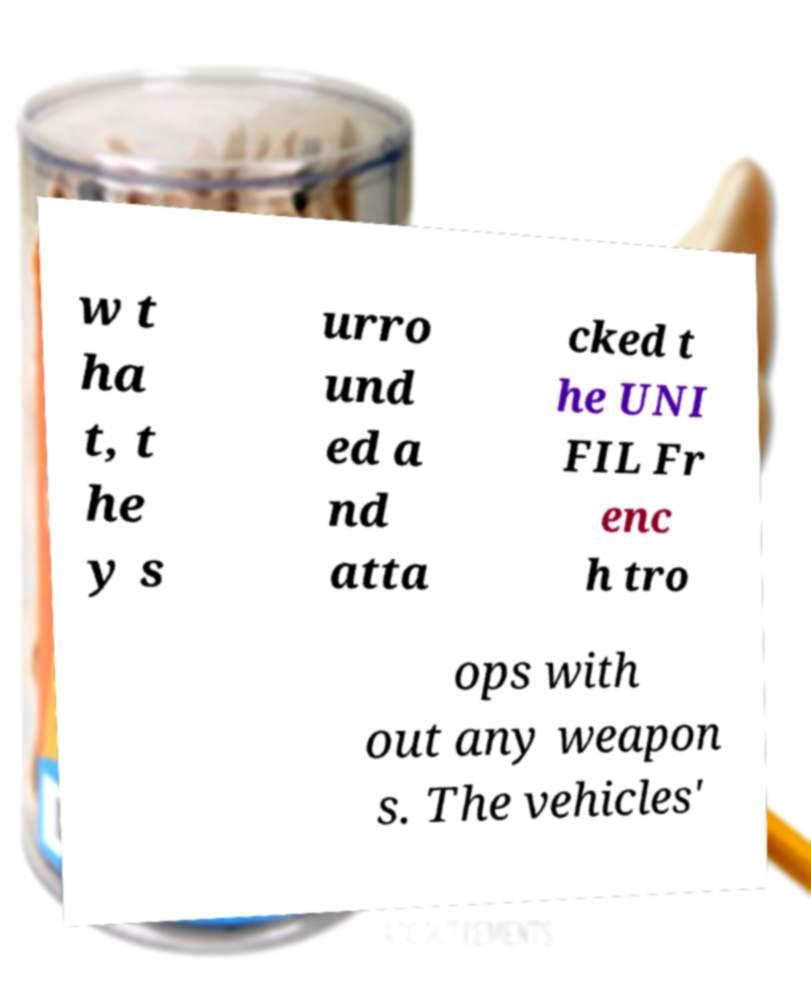Can you accurately transcribe the text from the provided image for me? w t ha t, t he y s urro und ed a nd atta cked t he UNI FIL Fr enc h tro ops with out any weapon s. The vehicles' 